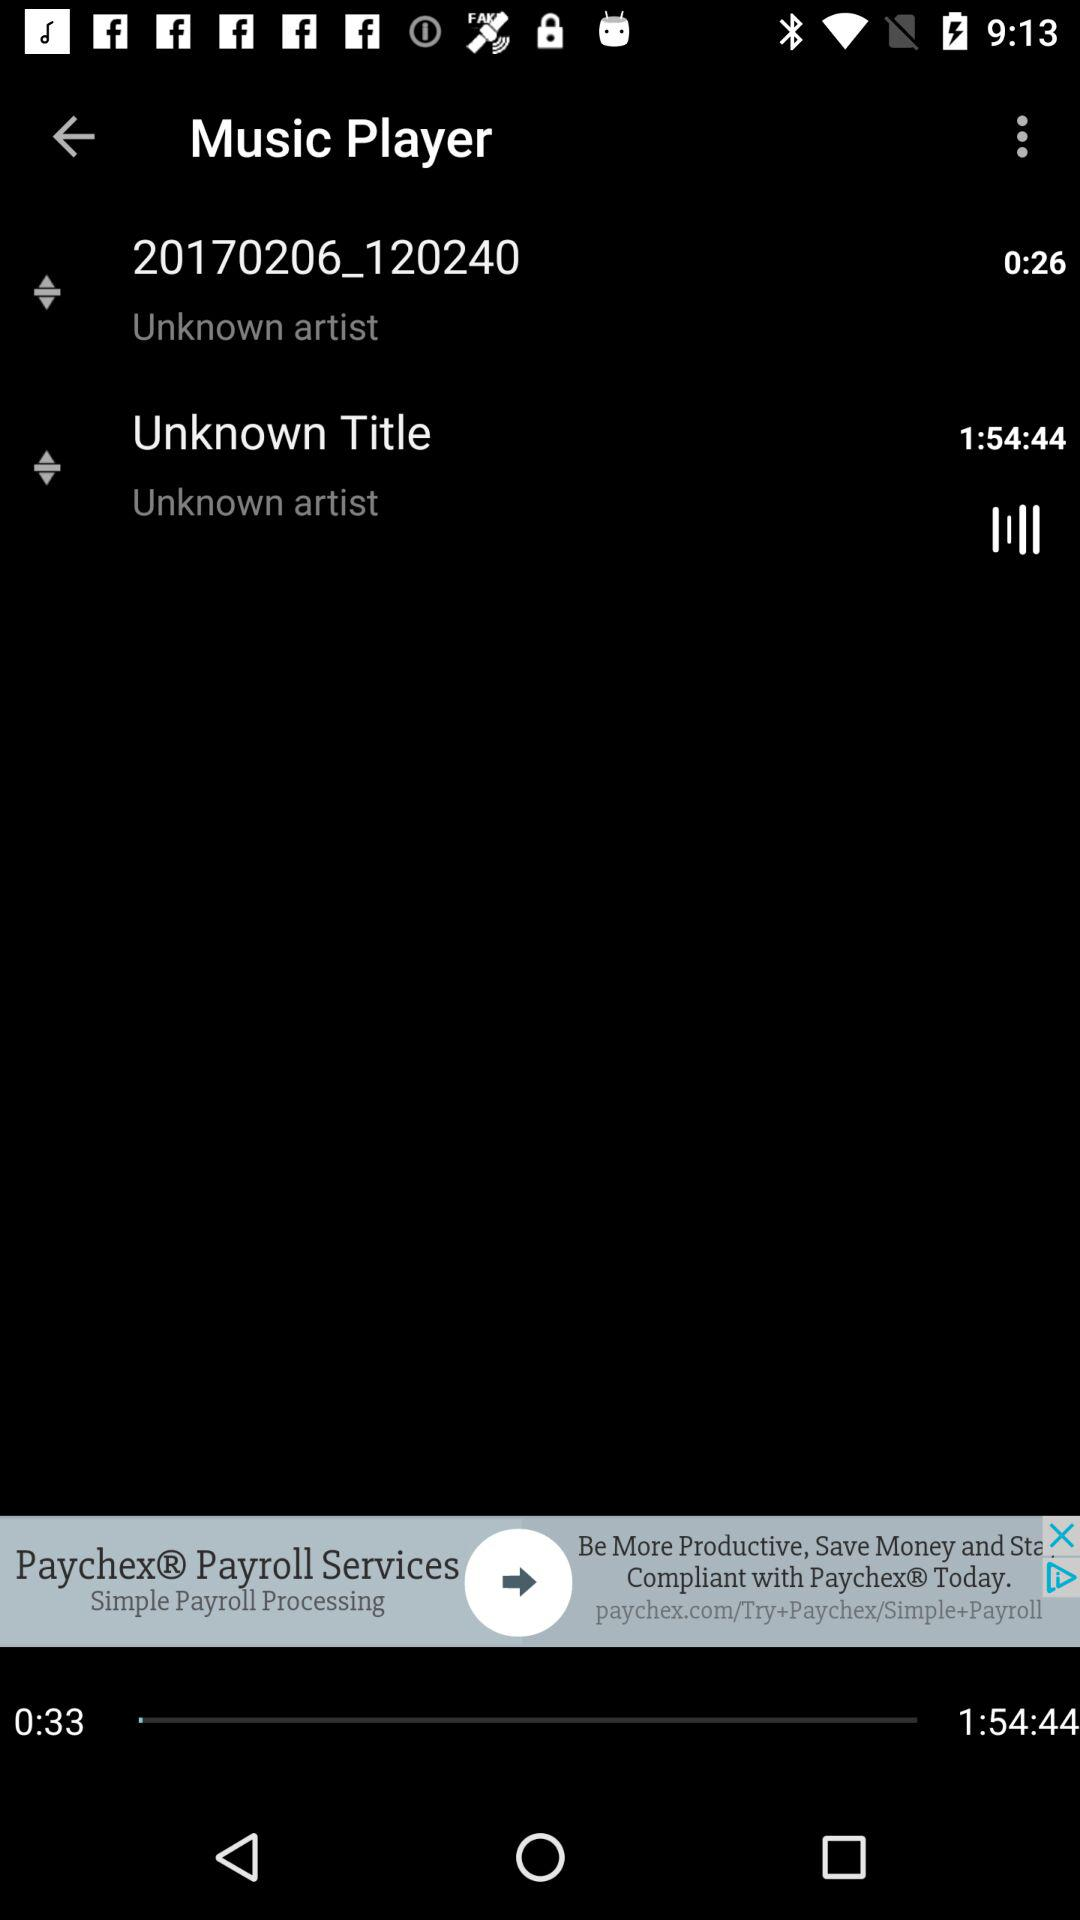What is the duration of the "Unknown Title"? The duration is 1:54:44. 